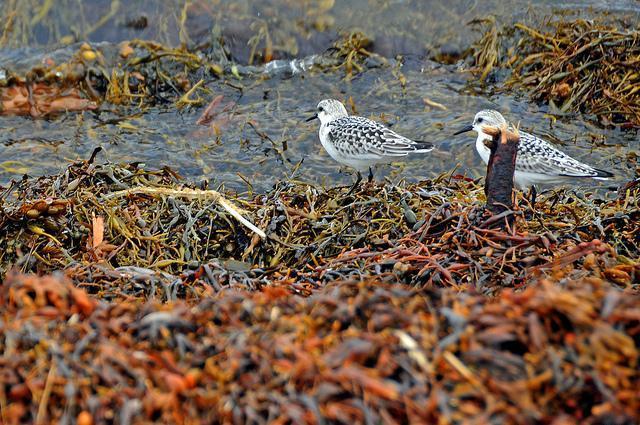How many birds are there?
Give a very brief answer. 2. How many cars are heading toward the train?
Give a very brief answer. 0. 